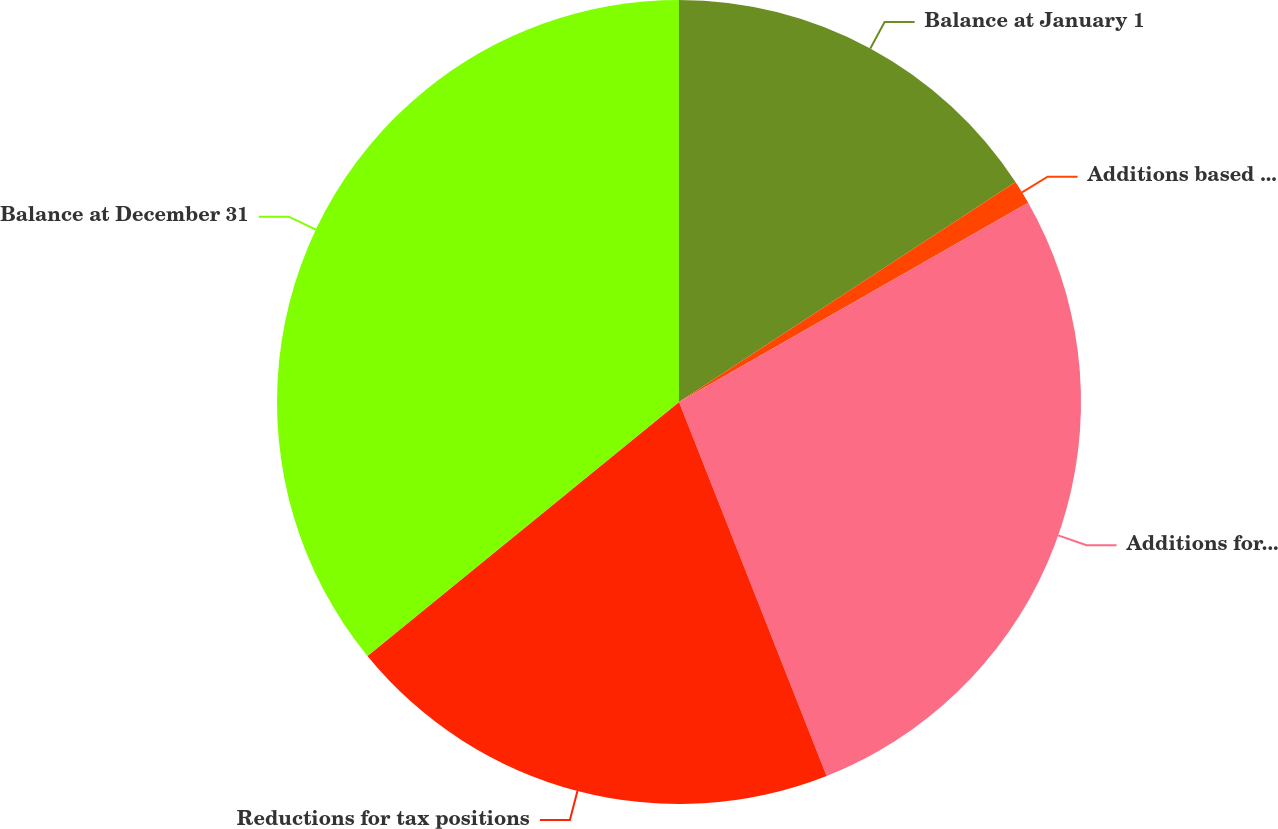Convert chart to OTSL. <chart><loc_0><loc_0><loc_500><loc_500><pie_chart><fcel>Balance at January 1<fcel>Additions based on tax<fcel>Additions for tax positions of<fcel>Reductions for tax positions<fcel>Balance at December 31<nl><fcel>15.79%<fcel>0.96%<fcel>27.27%<fcel>20.1%<fcel>35.89%<nl></chart> 